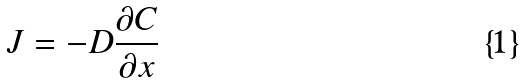Convert formula to latex. <formula><loc_0><loc_0><loc_500><loc_500>J = - D \frac { \partial C } { \partial x }</formula> 